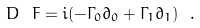<formula> <loc_0><loc_0><loc_500><loc_500>D _ { \ } F = i ( - \Gamma _ { 0 } \partial _ { 0 } + \Gamma _ { 1 } \partial _ { 1 } ) \ .</formula> 